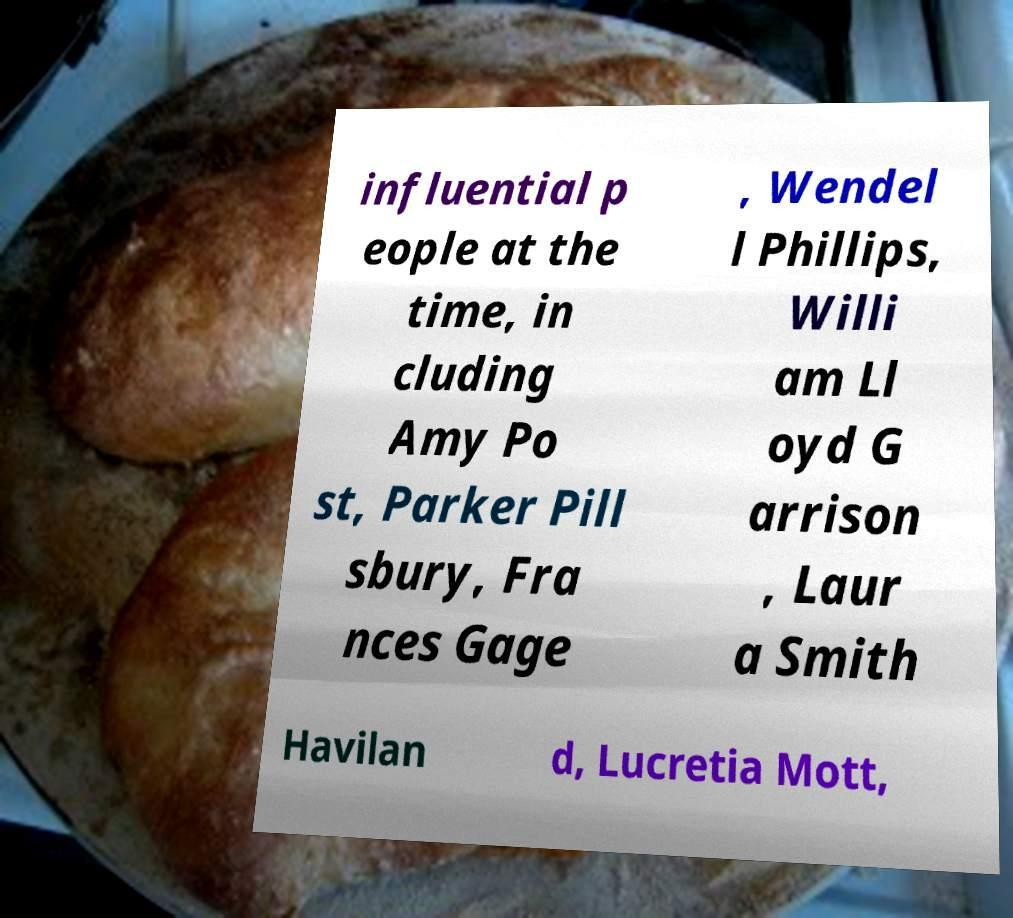Can you accurately transcribe the text from the provided image for me? influential p eople at the time, in cluding Amy Po st, Parker Pill sbury, Fra nces Gage , Wendel l Phillips, Willi am Ll oyd G arrison , Laur a Smith Havilan d, Lucretia Mott, 